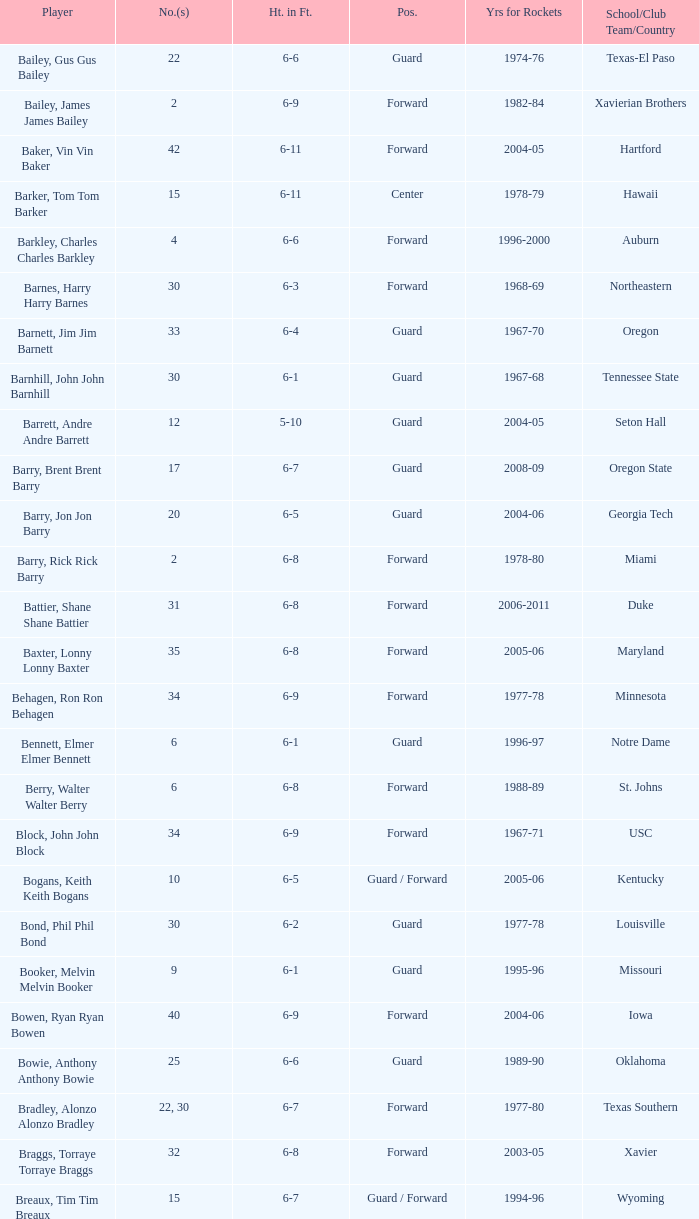Parse the full table. {'header': ['Player', 'No.(s)', 'Ht. in Ft.', 'Pos.', 'Yrs for Rockets', 'School/Club Team/Country'], 'rows': [['Bailey, Gus Gus Bailey', '22', '6-6', 'Guard', '1974-76', 'Texas-El Paso'], ['Bailey, James James Bailey', '2', '6-9', 'Forward', '1982-84', 'Xavierian Brothers'], ['Baker, Vin Vin Baker', '42', '6-11', 'Forward', '2004-05', 'Hartford'], ['Barker, Tom Tom Barker', '15', '6-11', 'Center', '1978-79', 'Hawaii'], ['Barkley, Charles Charles Barkley', '4', '6-6', 'Forward', '1996-2000', 'Auburn'], ['Barnes, Harry Harry Barnes', '30', '6-3', 'Forward', '1968-69', 'Northeastern'], ['Barnett, Jim Jim Barnett', '33', '6-4', 'Guard', '1967-70', 'Oregon'], ['Barnhill, John John Barnhill', '30', '6-1', 'Guard', '1967-68', 'Tennessee State'], ['Barrett, Andre Andre Barrett', '12', '5-10', 'Guard', '2004-05', 'Seton Hall'], ['Barry, Brent Brent Barry', '17', '6-7', 'Guard', '2008-09', 'Oregon State'], ['Barry, Jon Jon Barry', '20', '6-5', 'Guard', '2004-06', 'Georgia Tech'], ['Barry, Rick Rick Barry', '2', '6-8', 'Forward', '1978-80', 'Miami'], ['Battier, Shane Shane Battier', '31', '6-8', 'Forward', '2006-2011', 'Duke'], ['Baxter, Lonny Lonny Baxter', '35', '6-8', 'Forward', '2005-06', 'Maryland'], ['Behagen, Ron Ron Behagen', '34', '6-9', 'Forward', '1977-78', 'Minnesota'], ['Bennett, Elmer Elmer Bennett', '6', '6-1', 'Guard', '1996-97', 'Notre Dame'], ['Berry, Walter Walter Berry', '6', '6-8', 'Forward', '1988-89', 'St. Johns'], ['Block, John John Block', '34', '6-9', 'Forward', '1967-71', 'USC'], ['Bogans, Keith Keith Bogans', '10', '6-5', 'Guard / Forward', '2005-06', 'Kentucky'], ['Bond, Phil Phil Bond', '30', '6-2', 'Guard', '1977-78', 'Louisville'], ['Booker, Melvin Melvin Booker', '9', '6-1', 'Guard', '1995-96', 'Missouri'], ['Bowen, Ryan Ryan Bowen', '40', '6-9', 'Forward', '2004-06', 'Iowa'], ['Bowie, Anthony Anthony Bowie', '25', '6-6', 'Guard', '1989-90', 'Oklahoma'], ['Bradley, Alonzo Alonzo Bradley', '22, 30', '6-7', 'Forward', '1977-80', 'Texas Southern'], ['Braggs, Torraye Torraye Braggs', '32', '6-8', 'Forward', '2003-05', 'Xavier'], ['Breaux, Tim Tim Breaux', '15', '6-7', 'Guard / Forward', '1994-96', 'Wyoming'], ['Britt, Tyrone Tyrone Britt', '31', '6-4', 'Guard', '1967-68', 'Johnson C. Smith'], ['Brooks, Aaron Aaron Brooks', '0', '6-0', 'Guard', '2007-2011, 2013', 'Oregon'], ['Brooks, Scott Scott Brooks', '1', '5-11', 'Guard', '1992-95', 'UC-Irvine'], ['Brown, Chucky Chucky Brown', '52', '6-8', 'Forward', '1994-96', 'North Carolina'], ['Brown, Tony Tony Brown', '35', '6-6', 'Forward', '1988-89', 'Arkansas'], ['Brown, Tierre Tierre Brown', '10', '6-2', 'Guard', '2001-02', 'McNesse State'], ['Brunson, Rick Rick Brunson', '9', '6-4', 'Guard', '2005-06', 'Temple'], ['Bryant, Joe Joe Bryant', '22', '6-9', 'Forward / Guard', '1982-83', 'LaSalle'], ['Bryant, Mark Mark Bryant', '2', '6-9', 'Forward', '1995-96', 'Seton Hall'], ['Budinger, Chase Chase Budinger', '10', '6-7', 'Forward', '2009-2012', 'Arizona'], ['Bullard, Matt Matt Bullard', '50', '6-10', 'Forward', '1990-94, 1996-2001', 'Iowa']]} What years did the player from LaSalle play for the Rockets? 1982-83. 